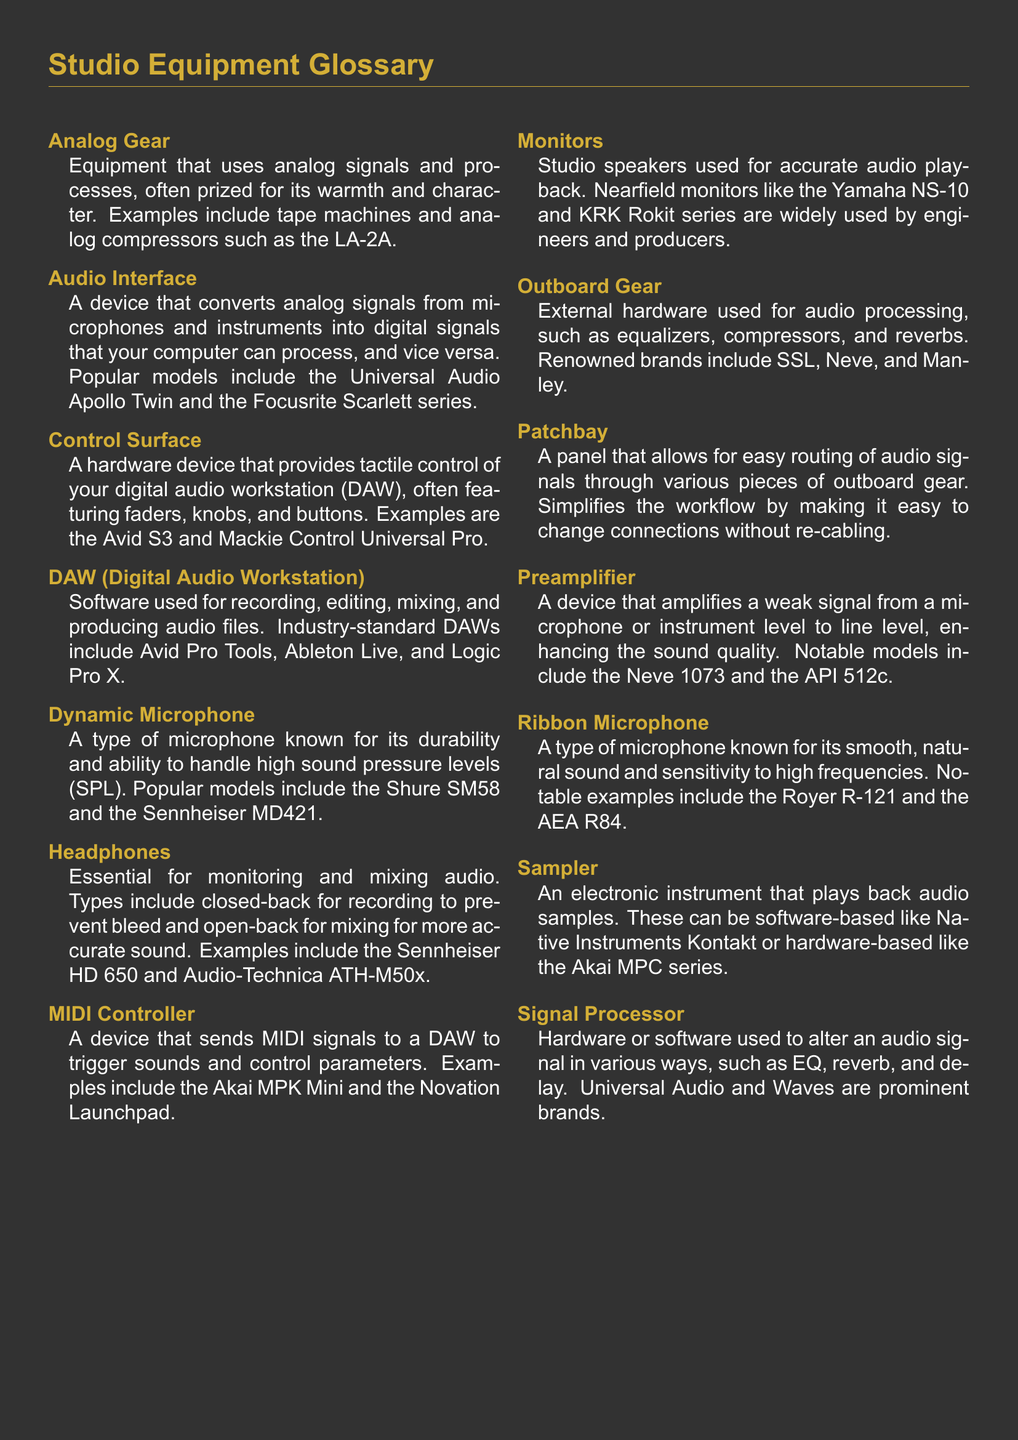What is an example of analog gear? Analog gear includes equipment that uses analog signals, and an example is the LA-2A.
Answer: LA-2A What does a MIDI controller do? A MIDI controller sends MIDI signals to a DAW to trigger sounds and control parameters.
Answer: Trigger sounds Which microphone type is known for durability? The dynamic microphone is known for its durability and ability to handle high sound pressure levels.
Answer: Dynamic Microphone What is a notable model of a preamplifier? The document lists notable models of preamplifiers, including the Neve 1073.
Answer: Neve 1073 What is the function of a patchbay? A patchbay allows for easy routing of audio signals through various pieces of outboard gear.
Answer: Easy routing What type of equipment is commonly used for accurate audio playback? Monitors are studio speakers used for accurate audio playback.
Answer: Monitors Can you name a popular DAW mentioned? Avid Pro Tools is one of the industry-standard DAWs mentioned in the document.
Answer: Avid Pro Tools Why are closed-back headphones preferred during recording? Closed-back headphones prevent sound bleed while recording, making them essential for monitoring.
Answer: Prevent bleed What is a sampler used for? A sampler is an electronic instrument that plays back audio samples.
Answer: Playback audio samples 